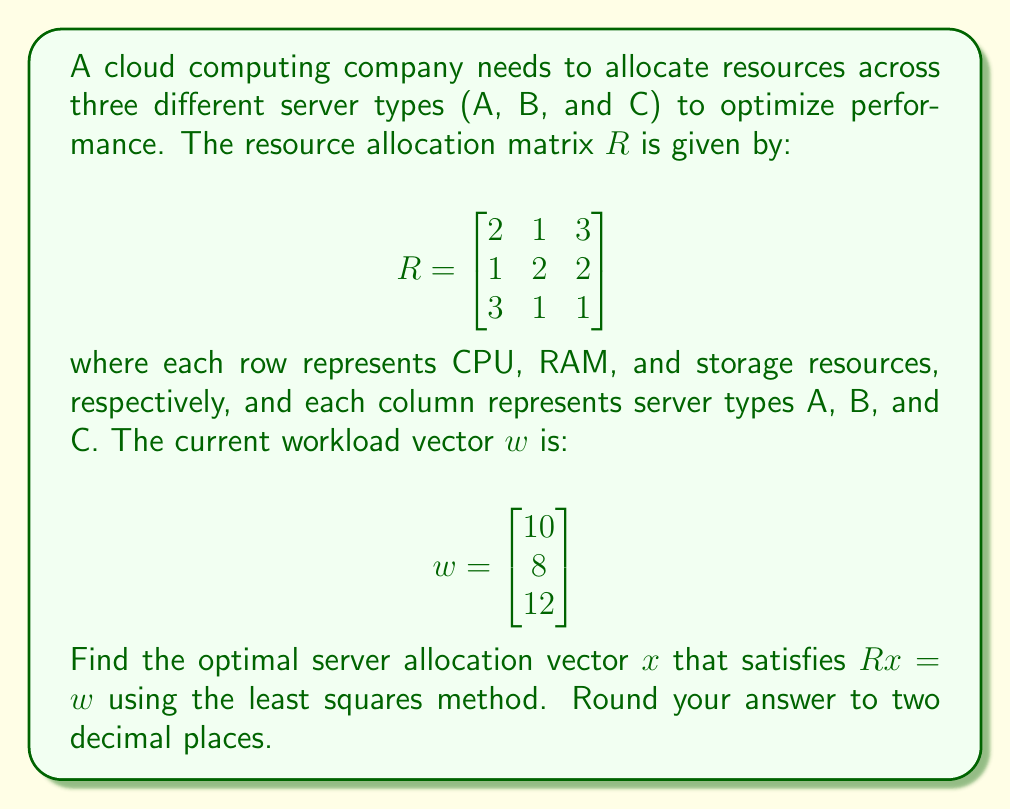Show me your answer to this math problem. To solve this problem, we'll use the least squares method from linear algebra. The steps are as follows:

1) The least squares solution is given by the formula:
   $$x = (R^TR)^{-1}R^Tw$$

2) First, let's calculate $R^T$:
   $$R^T = \begin{bmatrix}
   2 & 1 & 3 \\
   1 & 2 & 1 \\
   3 & 2 & 1
   \end{bmatrix}$$

3) Now, let's calculate $R^TR$:
   $$R^TR = \begin{bmatrix}
   2 & 1 & 3 \\
   1 & 2 & 1 \\
   3 & 2 & 1
   \end{bmatrix} \begin{bmatrix}
   2 & 1 & 3 \\
   1 & 2 & 2 \\
   3 & 1 & 1
   \end{bmatrix} = \begin{bmatrix}
   14 & 7 & 9 \\
   7 & 6 & 7 \\
   9 & 7 & 14
   \end{bmatrix}$$

4) Next, we need to find $(R^TR)^{-1}$. We can use a calculator or computer for this step:
   $$(R^TR)^{-1} \approx \begin{bmatrix}
   0.1429 & -0.1429 & 0 \\
   -0.1429 & 0.3571 & -0.1429 \\
   0 & -0.1429 & 0.1429
   \end{bmatrix}$$

5) Now, let's calculate $R^Tw$:
   $$R^Tw = \begin{bmatrix}
   2 & 1 & 3 \\
   1 & 2 & 1 \\
   3 & 2 & 1
   \end{bmatrix} \begin{bmatrix}
   10 \\
   8 \\
   12
   \end{bmatrix} = \begin{bmatrix}
   56 \\
   38 \\
   52
   \end{bmatrix}$$

6) Finally, we can calculate $x$:
   $$x = (R^TR)^{-1}R^Tw \approx \begin{bmatrix}
   0.1429 & -0.1429 & 0 \\
   -0.1429 & 0.3571 & -0.1429 \\
   0 & -0.1429 & 0.1429
   \end{bmatrix} \begin{bmatrix}
   56 \\
   38 \\
   52
   \end{bmatrix} \approx \begin{bmatrix}
   2.57 \\
   3.43 \\
   4.00
   \end{bmatrix}$$

7) Rounding to two decimal places, we get the final answer.
Answer: $x \approx [2.57, 3.43, 4.00]^T$ 